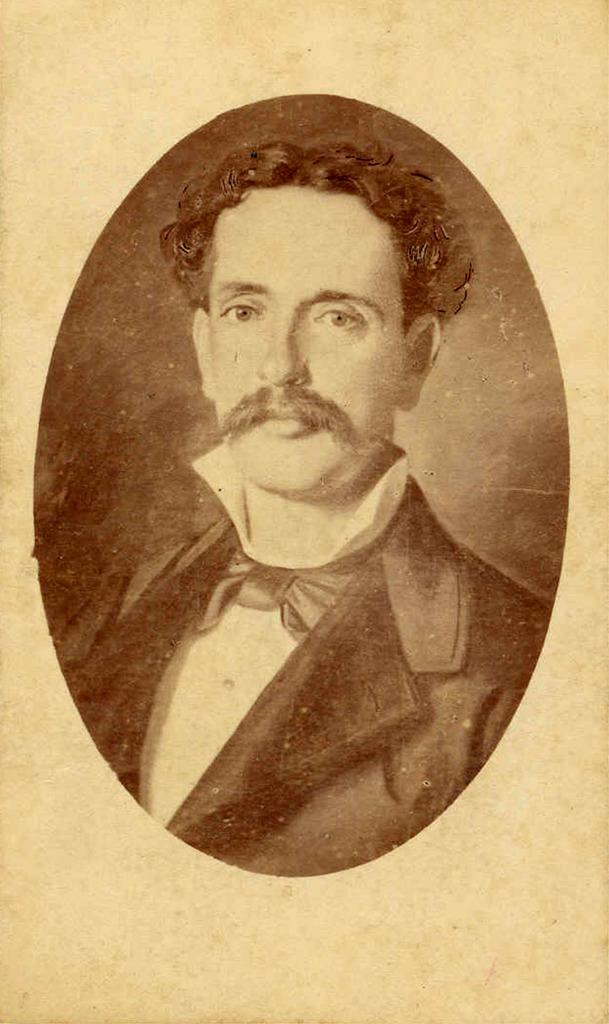What is the main subject of the image? There is a photo of a man in the image. What type of game is the man playing in the image? There is no game present in the image; it only features a photo of a man. Is there a lamp visible in the image? There is no lamp mentioned or visible in the image. 